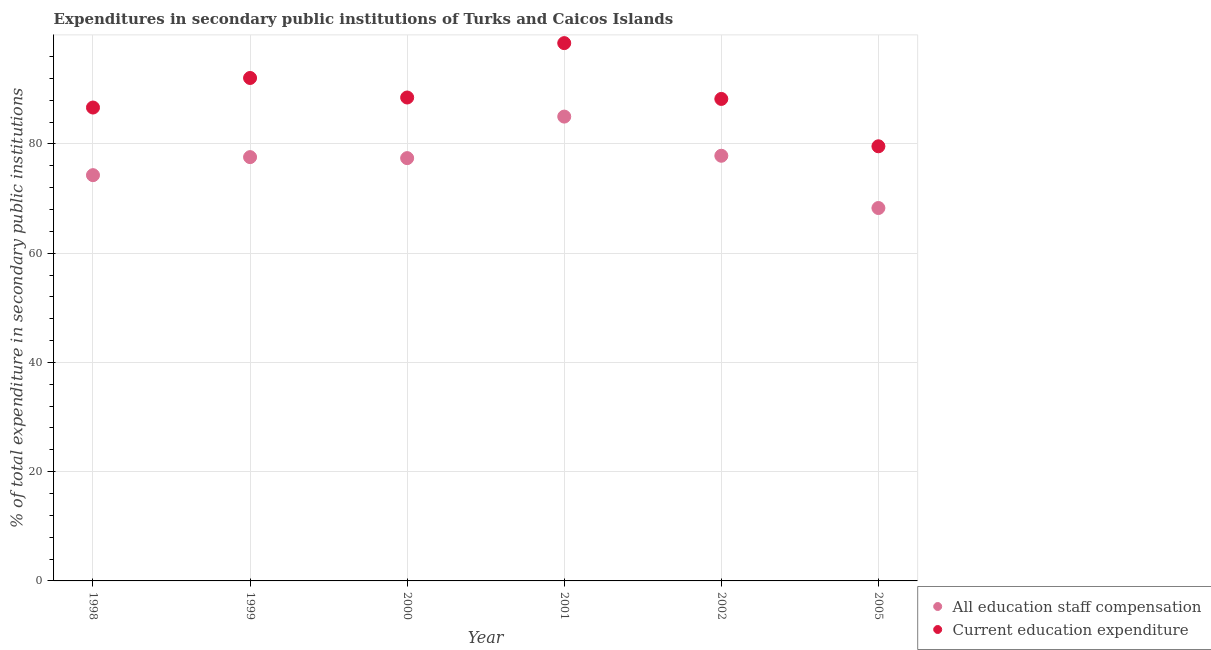Is the number of dotlines equal to the number of legend labels?
Keep it short and to the point. Yes. What is the expenditure in staff compensation in 1999?
Provide a short and direct response. 77.59. Across all years, what is the maximum expenditure in staff compensation?
Provide a succinct answer. 85.01. Across all years, what is the minimum expenditure in education?
Ensure brevity in your answer.  79.57. In which year was the expenditure in education maximum?
Provide a succinct answer. 2001. What is the total expenditure in staff compensation in the graph?
Your response must be concise. 460.39. What is the difference between the expenditure in staff compensation in 1998 and that in 2002?
Make the answer very short. -3.55. What is the difference between the expenditure in staff compensation in 1999 and the expenditure in education in 2002?
Keep it short and to the point. -10.65. What is the average expenditure in education per year?
Provide a succinct answer. 88.92. In the year 2001, what is the difference between the expenditure in education and expenditure in staff compensation?
Give a very brief answer. 13.45. In how many years, is the expenditure in education greater than 84 %?
Make the answer very short. 5. What is the ratio of the expenditure in staff compensation in 2001 to that in 2002?
Your response must be concise. 1.09. Is the expenditure in education in 1998 less than that in 2002?
Your answer should be very brief. Yes. What is the difference between the highest and the second highest expenditure in staff compensation?
Ensure brevity in your answer.  7.17. What is the difference between the highest and the lowest expenditure in staff compensation?
Offer a terse response. 16.74. Does the expenditure in education monotonically increase over the years?
Keep it short and to the point. No. Is the expenditure in staff compensation strictly greater than the expenditure in education over the years?
Your answer should be compact. No. Is the expenditure in staff compensation strictly less than the expenditure in education over the years?
Your answer should be very brief. Yes. How many dotlines are there?
Offer a very short reply. 2. How many years are there in the graph?
Provide a succinct answer. 6. What is the difference between two consecutive major ticks on the Y-axis?
Your answer should be compact. 20. Does the graph contain grids?
Your answer should be very brief. Yes. How many legend labels are there?
Your response must be concise. 2. What is the title of the graph?
Your response must be concise. Expenditures in secondary public institutions of Turks and Caicos Islands. Does "Resident" appear as one of the legend labels in the graph?
Provide a succinct answer. No. What is the label or title of the Y-axis?
Ensure brevity in your answer.  % of total expenditure in secondary public institutions. What is the % of total expenditure in secondary public institutions of All education staff compensation in 1998?
Ensure brevity in your answer.  74.29. What is the % of total expenditure in secondary public institutions of Current education expenditure in 1998?
Provide a short and direct response. 86.67. What is the % of total expenditure in secondary public institutions in All education staff compensation in 1999?
Make the answer very short. 77.59. What is the % of total expenditure in secondary public institutions in Current education expenditure in 1999?
Your answer should be very brief. 92.08. What is the % of total expenditure in secondary public institutions of All education staff compensation in 2000?
Keep it short and to the point. 77.41. What is the % of total expenditure in secondary public institutions in Current education expenditure in 2000?
Provide a short and direct response. 88.5. What is the % of total expenditure in secondary public institutions of All education staff compensation in 2001?
Provide a short and direct response. 85.01. What is the % of total expenditure in secondary public institutions of Current education expenditure in 2001?
Give a very brief answer. 98.46. What is the % of total expenditure in secondary public institutions of All education staff compensation in 2002?
Make the answer very short. 77.84. What is the % of total expenditure in secondary public institutions in Current education expenditure in 2002?
Keep it short and to the point. 88.24. What is the % of total expenditure in secondary public institutions in All education staff compensation in 2005?
Your answer should be compact. 68.27. What is the % of total expenditure in secondary public institutions of Current education expenditure in 2005?
Your answer should be very brief. 79.57. Across all years, what is the maximum % of total expenditure in secondary public institutions of All education staff compensation?
Provide a short and direct response. 85.01. Across all years, what is the maximum % of total expenditure in secondary public institutions in Current education expenditure?
Your response must be concise. 98.46. Across all years, what is the minimum % of total expenditure in secondary public institutions in All education staff compensation?
Make the answer very short. 68.27. Across all years, what is the minimum % of total expenditure in secondary public institutions in Current education expenditure?
Provide a succinct answer. 79.57. What is the total % of total expenditure in secondary public institutions of All education staff compensation in the graph?
Offer a very short reply. 460.39. What is the total % of total expenditure in secondary public institutions in Current education expenditure in the graph?
Keep it short and to the point. 533.52. What is the difference between the % of total expenditure in secondary public institutions in All education staff compensation in 1998 and that in 1999?
Your response must be concise. -3.3. What is the difference between the % of total expenditure in secondary public institutions in Current education expenditure in 1998 and that in 1999?
Provide a succinct answer. -5.41. What is the difference between the % of total expenditure in secondary public institutions in All education staff compensation in 1998 and that in 2000?
Keep it short and to the point. -3.12. What is the difference between the % of total expenditure in secondary public institutions of Current education expenditure in 1998 and that in 2000?
Provide a succinct answer. -1.84. What is the difference between the % of total expenditure in secondary public institutions of All education staff compensation in 1998 and that in 2001?
Your answer should be compact. -10.72. What is the difference between the % of total expenditure in secondary public institutions in Current education expenditure in 1998 and that in 2001?
Offer a very short reply. -11.79. What is the difference between the % of total expenditure in secondary public institutions of All education staff compensation in 1998 and that in 2002?
Provide a short and direct response. -3.55. What is the difference between the % of total expenditure in secondary public institutions in Current education expenditure in 1998 and that in 2002?
Your answer should be very brief. -1.58. What is the difference between the % of total expenditure in secondary public institutions in All education staff compensation in 1998 and that in 2005?
Give a very brief answer. 6.02. What is the difference between the % of total expenditure in secondary public institutions of Current education expenditure in 1998 and that in 2005?
Provide a succinct answer. 7.1. What is the difference between the % of total expenditure in secondary public institutions of All education staff compensation in 1999 and that in 2000?
Provide a succinct answer. 0.18. What is the difference between the % of total expenditure in secondary public institutions of Current education expenditure in 1999 and that in 2000?
Keep it short and to the point. 3.57. What is the difference between the % of total expenditure in secondary public institutions of All education staff compensation in 1999 and that in 2001?
Provide a short and direct response. -7.42. What is the difference between the % of total expenditure in secondary public institutions of Current education expenditure in 1999 and that in 2001?
Provide a short and direct response. -6.38. What is the difference between the % of total expenditure in secondary public institutions of All education staff compensation in 1999 and that in 2002?
Provide a short and direct response. -0.25. What is the difference between the % of total expenditure in secondary public institutions of Current education expenditure in 1999 and that in 2002?
Keep it short and to the point. 3.83. What is the difference between the % of total expenditure in secondary public institutions of All education staff compensation in 1999 and that in 2005?
Your response must be concise. 9.32. What is the difference between the % of total expenditure in secondary public institutions in Current education expenditure in 1999 and that in 2005?
Offer a terse response. 12.51. What is the difference between the % of total expenditure in secondary public institutions in All education staff compensation in 2000 and that in 2001?
Your answer should be compact. -7.6. What is the difference between the % of total expenditure in secondary public institutions of Current education expenditure in 2000 and that in 2001?
Make the answer very short. -9.96. What is the difference between the % of total expenditure in secondary public institutions in All education staff compensation in 2000 and that in 2002?
Offer a terse response. -0.43. What is the difference between the % of total expenditure in secondary public institutions of Current education expenditure in 2000 and that in 2002?
Ensure brevity in your answer.  0.26. What is the difference between the % of total expenditure in secondary public institutions in All education staff compensation in 2000 and that in 2005?
Offer a terse response. 9.13. What is the difference between the % of total expenditure in secondary public institutions in Current education expenditure in 2000 and that in 2005?
Your response must be concise. 8.93. What is the difference between the % of total expenditure in secondary public institutions of All education staff compensation in 2001 and that in 2002?
Keep it short and to the point. 7.17. What is the difference between the % of total expenditure in secondary public institutions of Current education expenditure in 2001 and that in 2002?
Make the answer very short. 10.22. What is the difference between the % of total expenditure in secondary public institutions of All education staff compensation in 2001 and that in 2005?
Provide a short and direct response. 16.74. What is the difference between the % of total expenditure in secondary public institutions of Current education expenditure in 2001 and that in 2005?
Offer a terse response. 18.89. What is the difference between the % of total expenditure in secondary public institutions of All education staff compensation in 2002 and that in 2005?
Your answer should be compact. 9.57. What is the difference between the % of total expenditure in secondary public institutions in Current education expenditure in 2002 and that in 2005?
Offer a very short reply. 8.67. What is the difference between the % of total expenditure in secondary public institutions in All education staff compensation in 1998 and the % of total expenditure in secondary public institutions in Current education expenditure in 1999?
Your answer should be compact. -17.79. What is the difference between the % of total expenditure in secondary public institutions in All education staff compensation in 1998 and the % of total expenditure in secondary public institutions in Current education expenditure in 2000?
Ensure brevity in your answer.  -14.22. What is the difference between the % of total expenditure in secondary public institutions in All education staff compensation in 1998 and the % of total expenditure in secondary public institutions in Current education expenditure in 2001?
Ensure brevity in your answer.  -24.17. What is the difference between the % of total expenditure in secondary public institutions in All education staff compensation in 1998 and the % of total expenditure in secondary public institutions in Current education expenditure in 2002?
Your response must be concise. -13.96. What is the difference between the % of total expenditure in secondary public institutions in All education staff compensation in 1998 and the % of total expenditure in secondary public institutions in Current education expenditure in 2005?
Your response must be concise. -5.29. What is the difference between the % of total expenditure in secondary public institutions of All education staff compensation in 1999 and the % of total expenditure in secondary public institutions of Current education expenditure in 2000?
Keep it short and to the point. -10.91. What is the difference between the % of total expenditure in secondary public institutions of All education staff compensation in 1999 and the % of total expenditure in secondary public institutions of Current education expenditure in 2001?
Provide a succinct answer. -20.87. What is the difference between the % of total expenditure in secondary public institutions in All education staff compensation in 1999 and the % of total expenditure in secondary public institutions in Current education expenditure in 2002?
Offer a terse response. -10.65. What is the difference between the % of total expenditure in secondary public institutions of All education staff compensation in 1999 and the % of total expenditure in secondary public institutions of Current education expenditure in 2005?
Your response must be concise. -1.98. What is the difference between the % of total expenditure in secondary public institutions of All education staff compensation in 2000 and the % of total expenditure in secondary public institutions of Current education expenditure in 2001?
Ensure brevity in your answer.  -21.05. What is the difference between the % of total expenditure in secondary public institutions in All education staff compensation in 2000 and the % of total expenditure in secondary public institutions in Current education expenditure in 2002?
Your answer should be compact. -10.84. What is the difference between the % of total expenditure in secondary public institutions of All education staff compensation in 2000 and the % of total expenditure in secondary public institutions of Current education expenditure in 2005?
Provide a succinct answer. -2.17. What is the difference between the % of total expenditure in secondary public institutions in All education staff compensation in 2001 and the % of total expenditure in secondary public institutions in Current education expenditure in 2002?
Provide a short and direct response. -3.23. What is the difference between the % of total expenditure in secondary public institutions in All education staff compensation in 2001 and the % of total expenditure in secondary public institutions in Current education expenditure in 2005?
Offer a terse response. 5.44. What is the difference between the % of total expenditure in secondary public institutions in All education staff compensation in 2002 and the % of total expenditure in secondary public institutions in Current education expenditure in 2005?
Make the answer very short. -1.73. What is the average % of total expenditure in secondary public institutions of All education staff compensation per year?
Make the answer very short. 76.73. What is the average % of total expenditure in secondary public institutions in Current education expenditure per year?
Offer a very short reply. 88.92. In the year 1998, what is the difference between the % of total expenditure in secondary public institutions in All education staff compensation and % of total expenditure in secondary public institutions in Current education expenditure?
Give a very brief answer. -12.38. In the year 1999, what is the difference between the % of total expenditure in secondary public institutions in All education staff compensation and % of total expenditure in secondary public institutions in Current education expenditure?
Offer a terse response. -14.49. In the year 2000, what is the difference between the % of total expenditure in secondary public institutions in All education staff compensation and % of total expenditure in secondary public institutions in Current education expenditure?
Your response must be concise. -11.1. In the year 2001, what is the difference between the % of total expenditure in secondary public institutions in All education staff compensation and % of total expenditure in secondary public institutions in Current education expenditure?
Provide a succinct answer. -13.45. In the year 2002, what is the difference between the % of total expenditure in secondary public institutions of All education staff compensation and % of total expenditure in secondary public institutions of Current education expenditure?
Offer a terse response. -10.41. In the year 2005, what is the difference between the % of total expenditure in secondary public institutions in All education staff compensation and % of total expenditure in secondary public institutions in Current education expenditure?
Provide a short and direct response. -11.3. What is the ratio of the % of total expenditure in secondary public institutions of All education staff compensation in 1998 to that in 1999?
Give a very brief answer. 0.96. What is the ratio of the % of total expenditure in secondary public institutions of Current education expenditure in 1998 to that in 1999?
Provide a short and direct response. 0.94. What is the ratio of the % of total expenditure in secondary public institutions of All education staff compensation in 1998 to that in 2000?
Make the answer very short. 0.96. What is the ratio of the % of total expenditure in secondary public institutions in Current education expenditure in 1998 to that in 2000?
Offer a terse response. 0.98. What is the ratio of the % of total expenditure in secondary public institutions of All education staff compensation in 1998 to that in 2001?
Your answer should be compact. 0.87. What is the ratio of the % of total expenditure in secondary public institutions of Current education expenditure in 1998 to that in 2001?
Your answer should be very brief. 0.88. What is the ratio of the % of total expenditure in secondary public institutions in All education staff compensation in 1998 to that in 2002?
Your answer should be very brief. 0.95. What is the ratio of the % of total expenditure in secondary public institutions of Current education expenditure in 1998 to that in 2002?
Offer a terse response. 0.98. What is the ratio of the % of total expenditure in secondary public institutions of All education staff compensation in 1998 to that in 2005?
Make the answer very short. 1.09. What is the ratio of the % of total expenditure in secondary public institutions of Current education expenditure in 1998 to that in 2005?
Your answer should be very brief. 1.09. What is the ratio of the % of total expenditure in secondary public institutions of Current education expenditure in 1999 to that in 2000?
Offer a terse response. 1.04. What is the ratio of the % of total expenditure in secondary public institutions in All education staff compensation in 1999 to that in 2001?
Offer a very short reply. 0.91. What is the ratio of the % of total expenditure in secondary public institutions of Current education expenditure in 1999 to that in 2001?
Give a very brief answer. 0.94. What is the ratio of the % of total expenditure in secondary public institutions of All education staff compensation in 1999 to that in 2002?
Offer a terse response. 1. What is the ratio of the % of total expenditure in secondary public institutions in Current education expenditure in 1999 to that in 2002?
Offer a terse response. 1.04. What is the ratio of the % of total expenditure in secondary public institutions in All education staff compensation in 1999 to that in 2005?
Your answer should be compact. 1.14. What is the ratio of the % of total expenditure in secondary public institutions in Current education expenditure in 1999 to that in 2005?
Provide a short and direct response. 1.16. What is the ratio of the % of total expenditure in secondary public institutions of All education staff compensation in 2000 to that in 2001?
Offer a very short reply. 0.91. What is the ratio of the % of total expenditure in secondary public institutions in Current education expenditure in 2000 to that in 2001?
Offer a terse response. 0.9. What is the ratio of the % of total expenditure in secondary public institutions in All education staff compensation in 2000 to that in 2002?
Provide a short and direct response. 0.99. What is the ratio of the % of total expenditure in secondary public institutions of Current education expenditure in 2000 to that in 2002?
Offer a very short reply. 1. What is the ratio of the % of total expenditure in secondary public institutions of All education staff compensation in 2000 to that in 2005?
Ensure brevity in your answer.  1.13. What is the ratio of the % of total expenditure in secondary public institutions of Current education expenditure in 2000 to that in 2005?
Provide a succinct answer. 1.11. What is the ratio of the % of total expenditure in secondary public institutions in All education staff compensation in 2001 to that in 2002?
Give a very brief answer. 1.09. What is the ratio of the % of total expenditure in secondary public institutions of Current education expenditure in 2001 to that in 2002?
Offer a very short reply. 1.12. What is the ratio of the % of total expenditure in secondary public institutions of All education staff compensation in 2001 to that in 2005?
Offer a very short reply. 1.25. What is the ratio of the % of total expenditure in secondary public institutions in Current education expenditure in 2001 to that in 2005?
Give a very brief answer. 1.24. What is the ratio of the % of total expenditure in secondary public institutions in All education staff compensation in 2002 to that in 2005?
Your answer should be very brief. 1.14. What is the ratio of the % of total expenditure in secondary public institutions in Current education expenditure in 2002 to that in 2005?
Keep it short and to the point. 1.11. What is the difference between the highest and the second highest % of total expenditure in secondary public institutions of All education staff compensation?
Keep it short and to the point. 7.17. What is the difference between the highest and the second highest % of total expenditure in secondary public institutions in Current education expenditure?
Your answer should be compact. 6.38. What is the difference between the highest and the lowest % of total expenditure in secondary public institutions of All education staff compensation?
Your answer should be very brief. 16.74. What is the difference between the highest and the lowest % of total expenditure in secondary public institutions in Current education expenditure?
Make the answer very short. 18.89. 